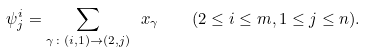Convert formula to latex. <formula><loc_0><loc_0><loc_500><loc_500>\psi ^ { i } _ { j } = \sum _ { \gamma \colon ( i , 1 ) \to ( 2 , j ) } \ x _ { \gamma } \quad ( 2 \leq i \leq m , 1 \leq j \leq n ) .</formula> 